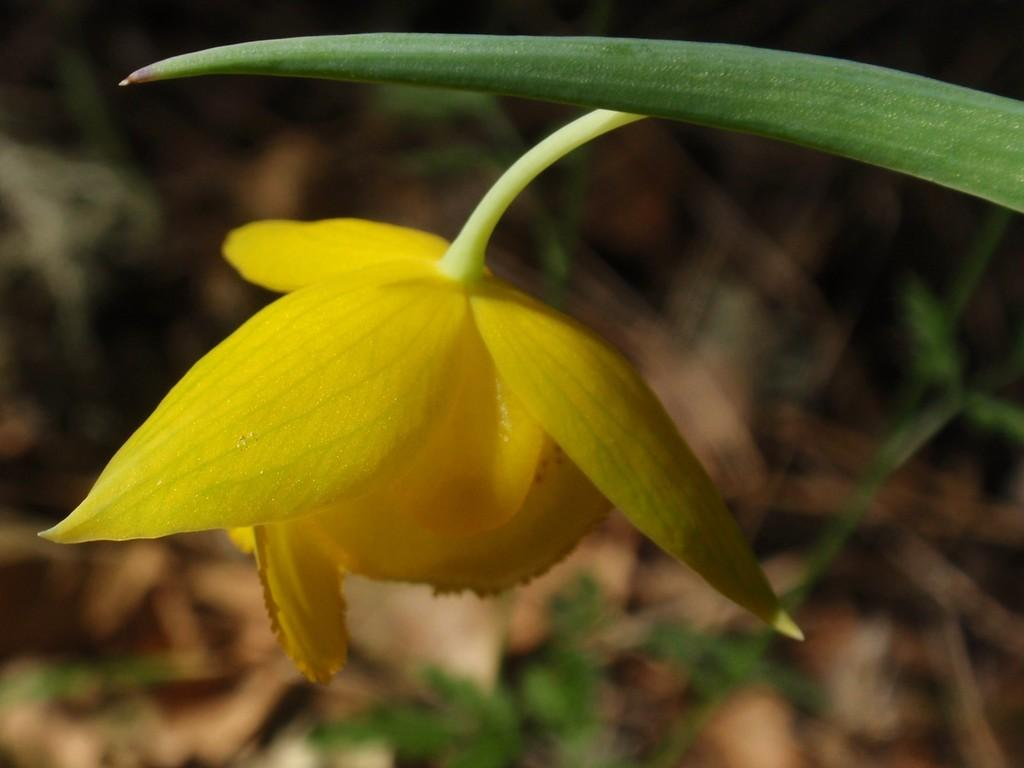What type of plant can be seen in the image? There is a flower in the image. What color is the flower? The flower is yellow. What other part of the plant is visible in the image? There is a leaf in the image. What color is the leaf? The leaf is green. How would you describe the background of the image? The background of the image is blurred. What type of class is being taught in the image? There is no class or teaching activity present in the image; it features a yellow flower and a green leaf with a blurred background. 